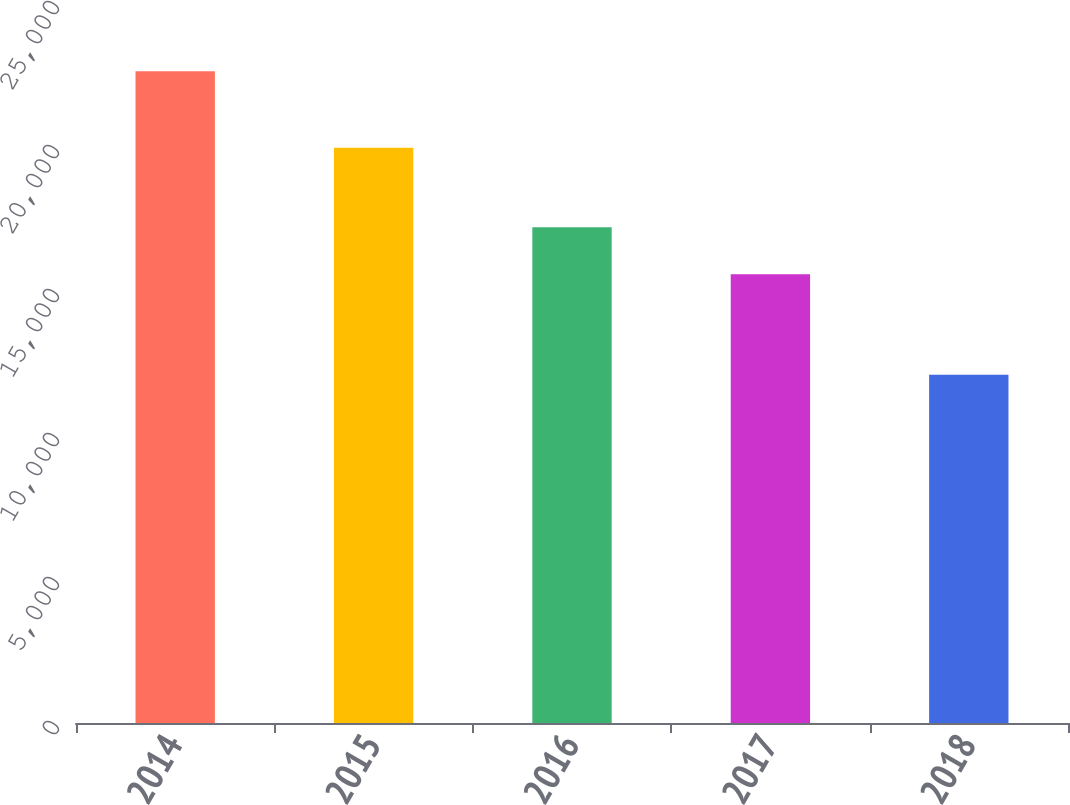Convert chart to OTSL. <chart><loc_0><loc_0><loc_500><loc_500><bar_chart><fcel>2014<fcel>2015<fcel>2016<fcel>2017<fcel>2018<nl><fcel>22630<fcel>19978<fcel>17211<fcel>15582<fcel>12094<nl></chart> 